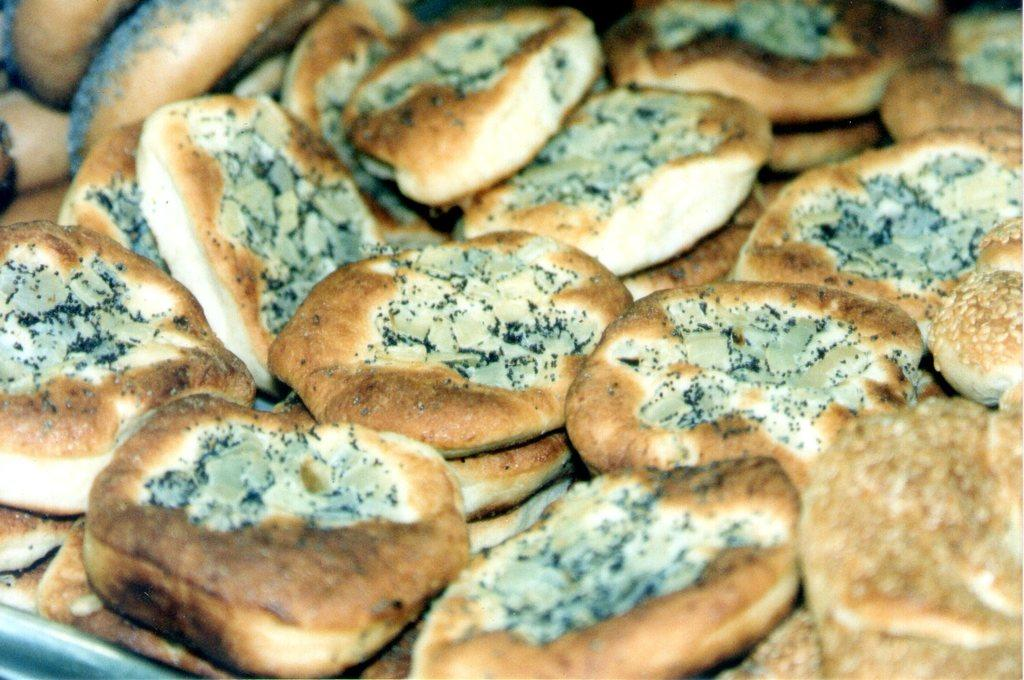What type of food is present in the image? There is bread in the image. Can you describe the colors of the bread? The bread has brown, black, and white colors. How many books are stacked on top of the bread in the image? There are no books present in the image; it only features bread. 